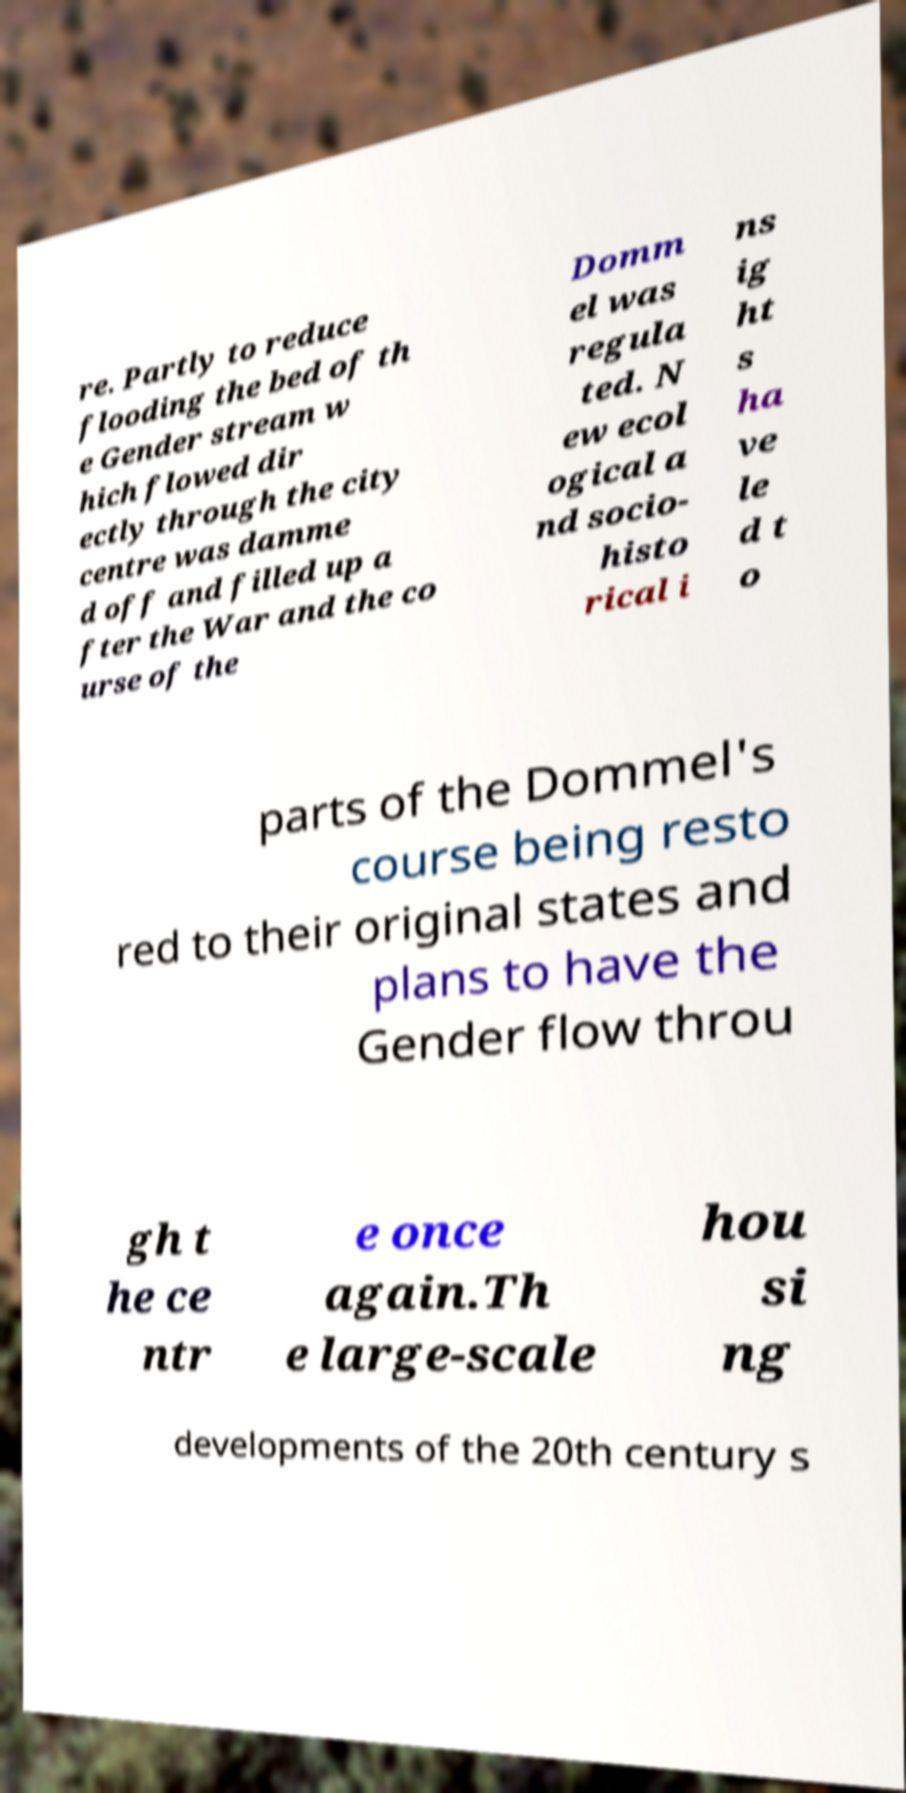For documentation purposes, I need the text within this image transcribed. Could you provide that? re. Partly to reduce flooding the bed of th e Gender stream w hich flowed dir ectly through the city centre was damme d off and filled up a fter the War and the co urse of the Domm el was regula ted. N ew ecol ogical a nd socio- histo rical i ns ig ht s ha ve le d t o parts of the Dommel's course being resto red to their original states and plans to have the Gender flow throu gh t he ce ntr e once again.Th e large-scale hou si ng developments of the 20th century s 